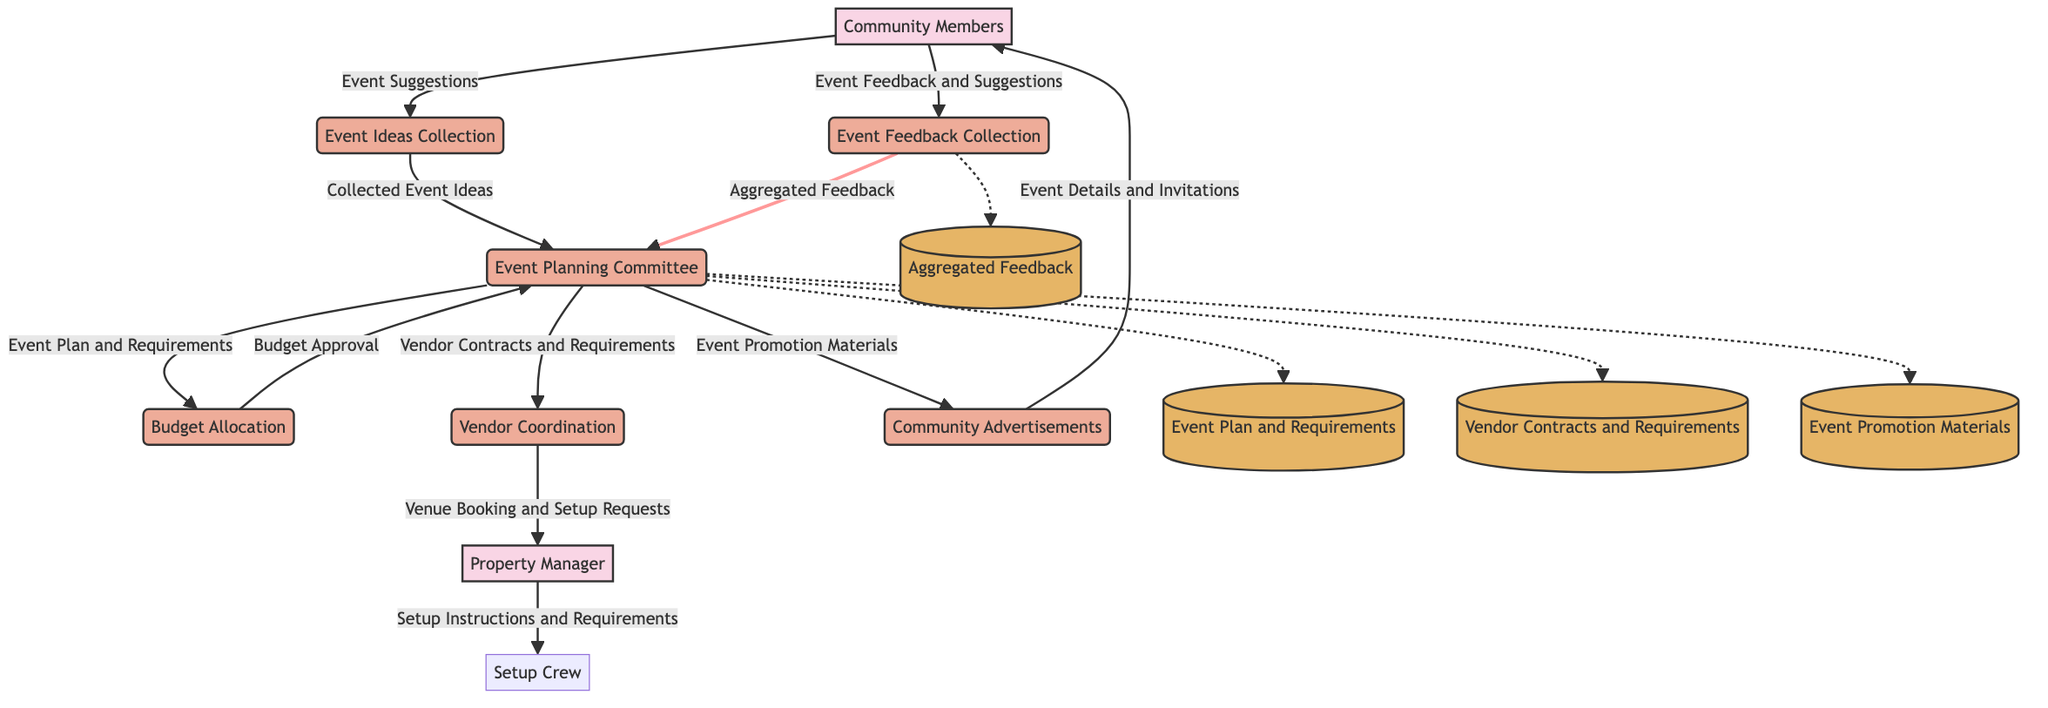What is the starting point of the data flow? The starting point is represented by "Community Members" who provide input in the form of "Event Suggestions."
Answer: Community Members How many main processes are involved in the diagram? There are six main processes: Event Ideas Collection, Event Planning Committee, Budget Allocation, Vendor Coordination, Community Advertisements, and Event Feedback Collection.
Answer: 6 Which entity is responsible for venue booking and setup requests? The entity that is responsible for venue booking and setup requests is the "Property Manager."
Answer: Property Manager What type of data flows from the Event Planning Committee to Community Advertisements? The data flow from the Event Planning Committee to Community Advertisements consists of "Event Promotion Materials."
Answer: Event Promotion Materials What will the Event Planning Committee receive from Budget Allocation? The Event Planning Committee will receive "Budget Approval" from Budget Allocation.
Answer: Budget Approval How many data stores are available in the diagram? There are four data stores: Event Plan and Requirements, Vendor Contracts and Requirements, Event Promotion Materials, and Aggregated Feedback.
Answer: 4 What data do Community Members provide to the Event Feedback Collection process? The data provided by Community Members to the Event Feedback Collection process is "Event Feedback and Suggestions."
Answer: Event Feedback and Suggestions Which two processes are directly interconnected with the flow of "Aggregated Feedback"? The two processes interconnected with "Aggregated Feedback" are Event Feedback Collection and Event Planning Committee.
Answer: Event Feedback Collection, Event Planning Committee How is the flow of data from Community Advertisements to Community Members represented? The flow of data is represented by "Event Details and Invitations" being sent to Community Members from Community Advertisements.
Answer: Event Details and Invitations 